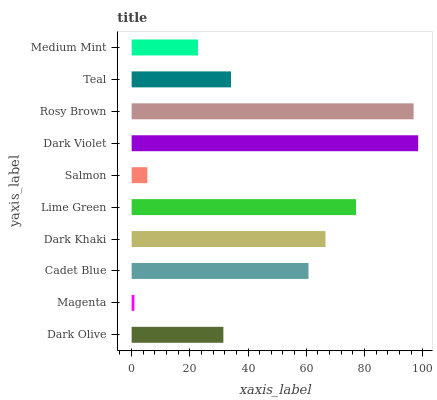Is Magenta the minimum?
Answer yes or no. Yes. Is Dark Violet the maximum?
Answer yes or no. Yes. Is Cadet Blue the minimum?
Answer yes or no. No. Is Cadet Blue the maximum?
Answer yes or no. No. Is Cadet Blue greater than Magenta?
Answer yes or no. Yes. Is Magenta less than Cadet Blue?
Answer yes or no. Yes. Is Magenta greater than Cadet Blue?
Answer yes or no. No. Is Cadet Blue less than Magenta?
Answer yes or no. No. Is Cadet Blue the high median?
Answer yes or no. Yes. Is Teal the low median?
Answer yes or no. Yes. Is Magenta the high median?
Answer yes or no. No. Is Magenta the low median?
Answer yes or no. No. 